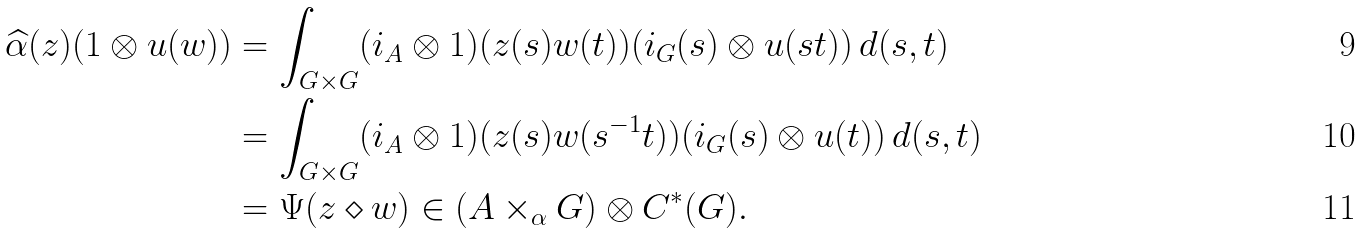Convert formula to latex. <formula><loc_0><loc_0><loc_500><loc_500>\widehat { \alpha } ( z ) ( 1 \otimes u ( w ) ) & = \int _ { G \times G } ( i _ { A } \otimes 1 ) ( z ( s ) w ( t ) ) ( i _ { G } ( s ) \otimes u ( s t ) ) \, d ( s , t ) \\ & = \int _ { G \times G } ( i _ { A } \otimes 1 ) ( z ( s ) w ( s ^ { - 1 } t ) ) ( i _ { G } ( s ) \otimes u ( t ) ) \, d ( s , t ) \\ & = \Psi ( z \diamond w ) \in ( A \times _ { \alpha } G ) \otimes C ^ { * } ( G ) .</formula> 